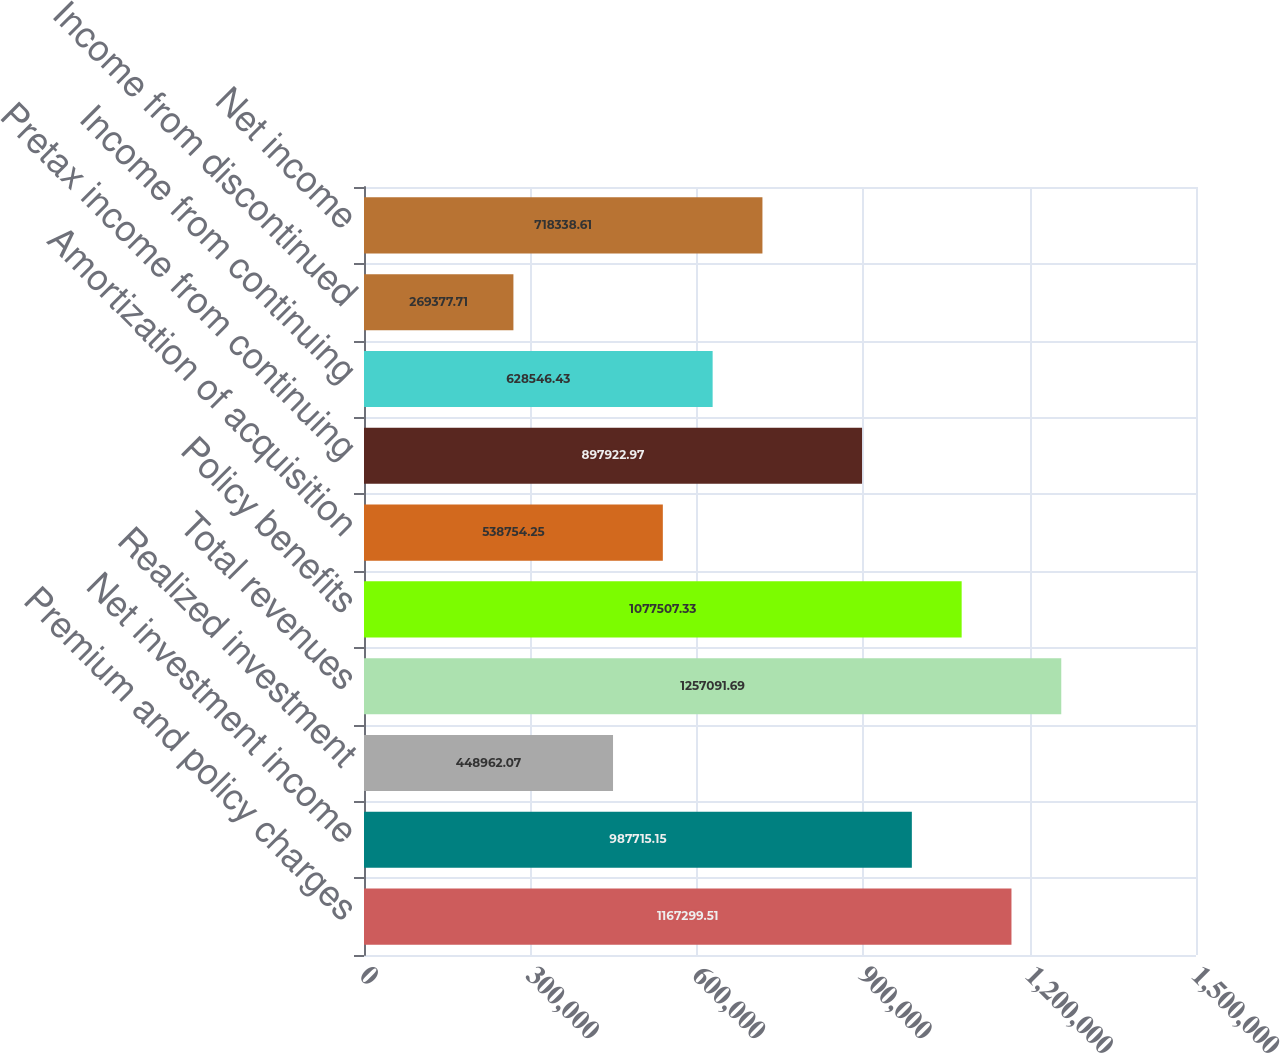Convert chart to OTSL. <chart><loc_0><loc_0><loc_500><loc_500><bar_chart><fcel>Premium and policy charges<fcel>Net investment income<fcel>Realized investment<fcel>Total revenues<fcel>Policy benefits<fcel>Amortization of acquisition<fcel>Pretax income from continuing<fcel>Income from continuing<fcel>Income from discontinued<fcel>Net income<nl><fcel>1.1673e+06<fcel>987715<fcel>448962<fcel>1.25709e+06<fcel>1.07751e+06<fcel>538754<fcel>897923<fcel>628546<fcel>269378<fcel>718339<nl></chart> 